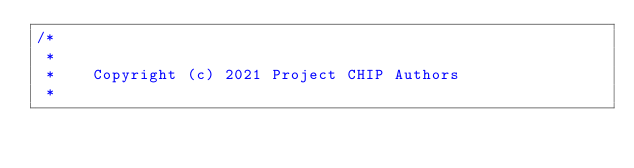<code> <loc_0><loc_0><loc_500><loc_500><_C_>/*
 *
 *    Copyright (c) 2021 Project CHIP Authors
 *</code> 